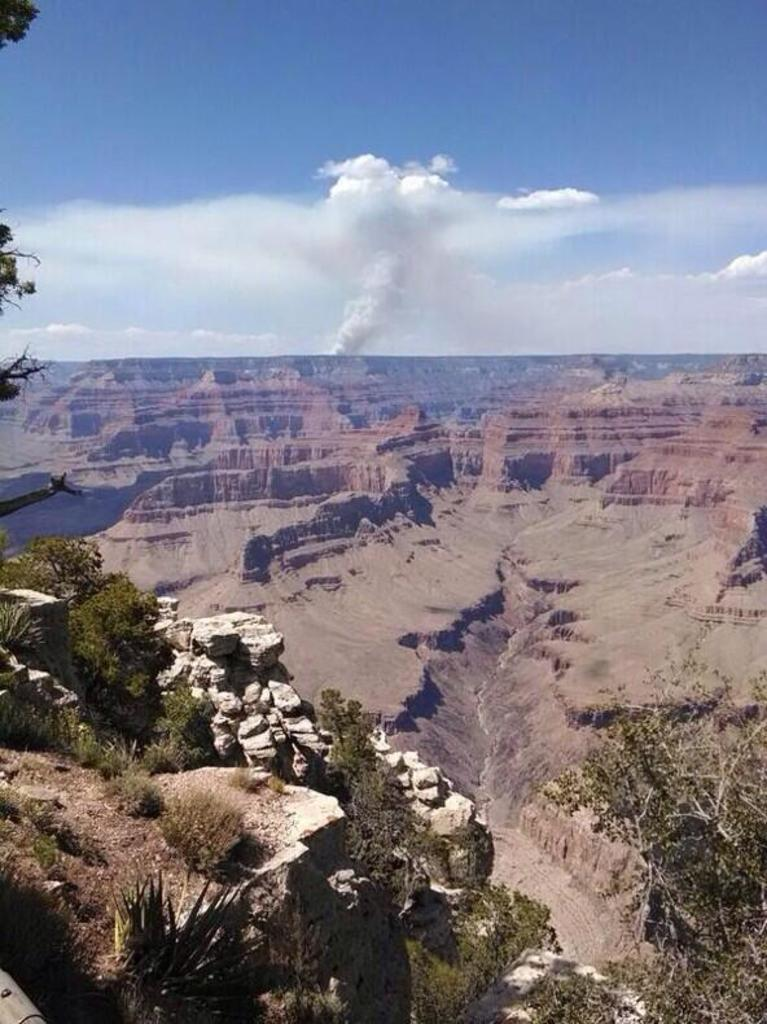What natural wonder is featured in the image? The image features the Grand Canyon. What type of geological formations can be seen in the image? There are rocks in the image. What type of vegetation is present in the image? Trees, bushes, and plants are visible in the image. What is on the ground in the image? Grass is on the ground in the image. What is the condition of the sky in the image? The sky is cloudy at the top of the image. Can you tell me how many parents are visible in the image? There are no parents present in the image; it features the Grand Canyon and its natural surroundings. Is there a mountain visible in the image? The Grand Canyon is a geological formation, not a mountain, so there is no mountain visible in the image. 